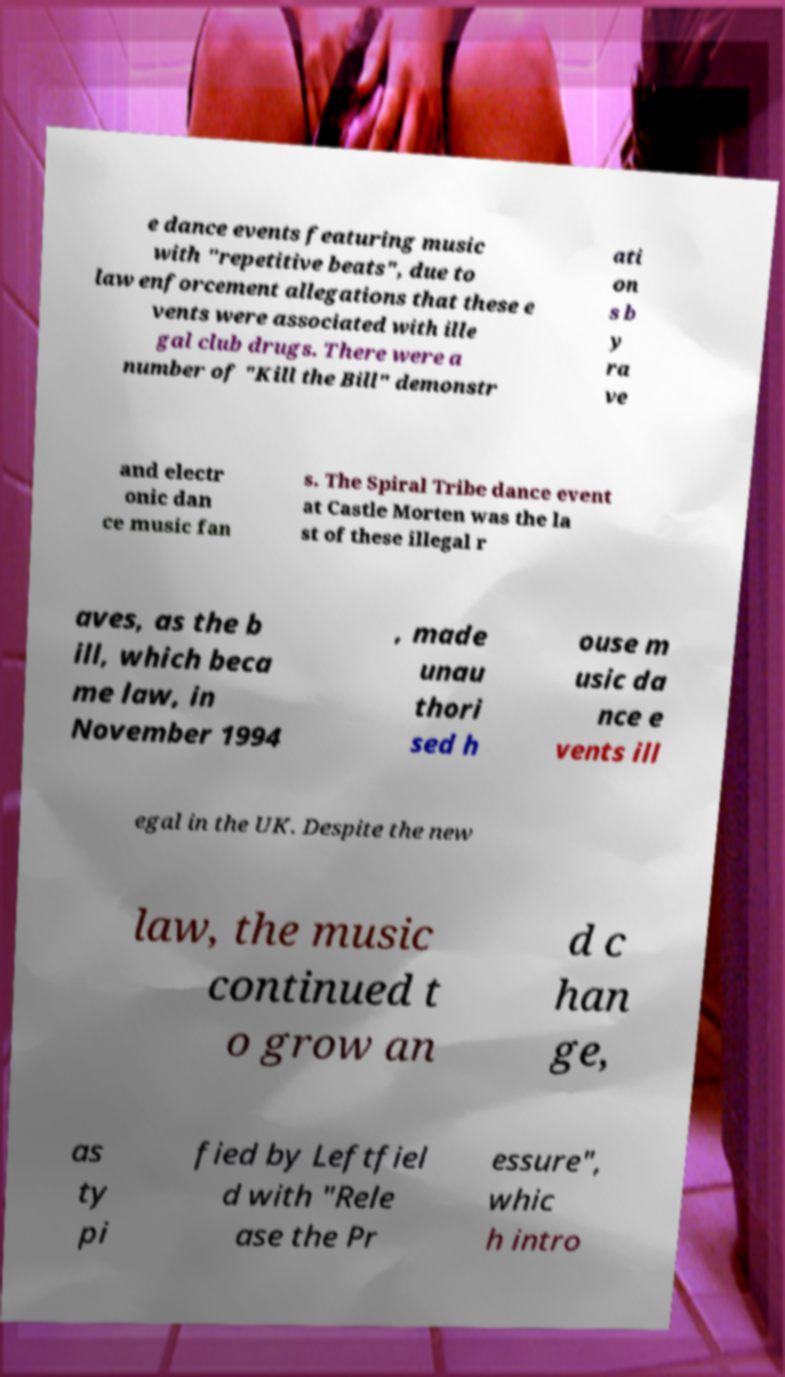Could you extract and type out the text from this image? e dance events featuring music with "repetitive beats", due to law enforcement allegations that these e vents were associated with ille gal club drugs. There were a number of "Kill the Bill" demonstr ati on s b y ra ve and electr onic dan ce music fan s. The Spiral Tribe dance event at Castle Morten was the la st of these illegal r aves, as the b ill, which beca me law, in November 1994 , made unau thori sed h ouse m usic da nce e vents ill egal in the UK. Despite the new law, the music continued t o grow an d c han ge, as ty pi fied by Leftfiel d with "Rele ase the Pr essure", whic h intro 